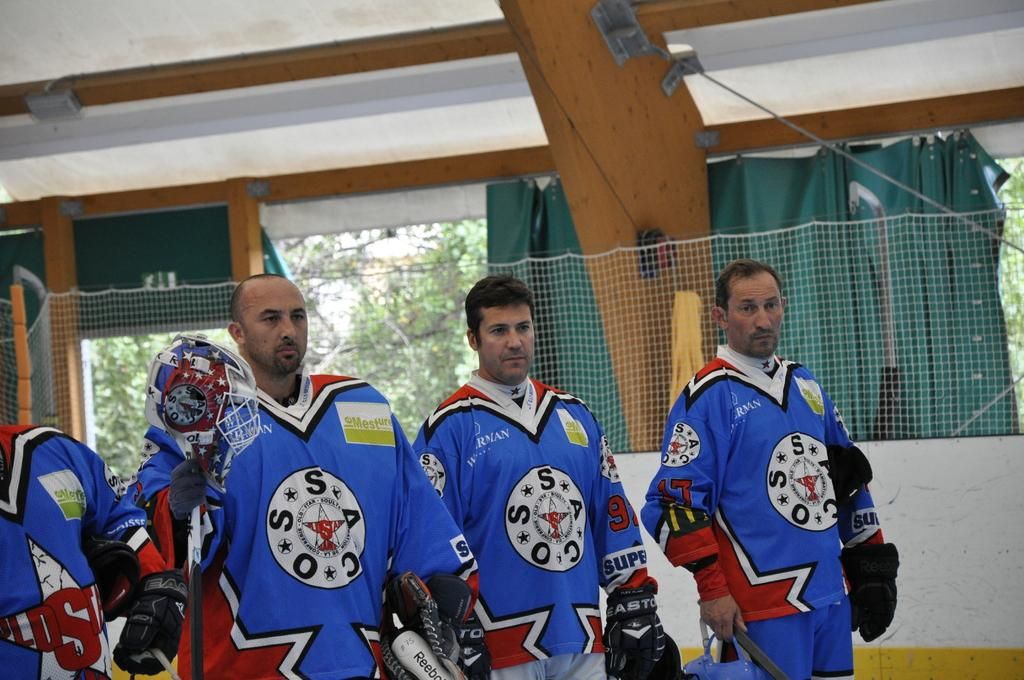<image>
Share a concise interpretation of the image provided. Three men stand together wearing blue jerseys with the letters COSSA in a circle. 